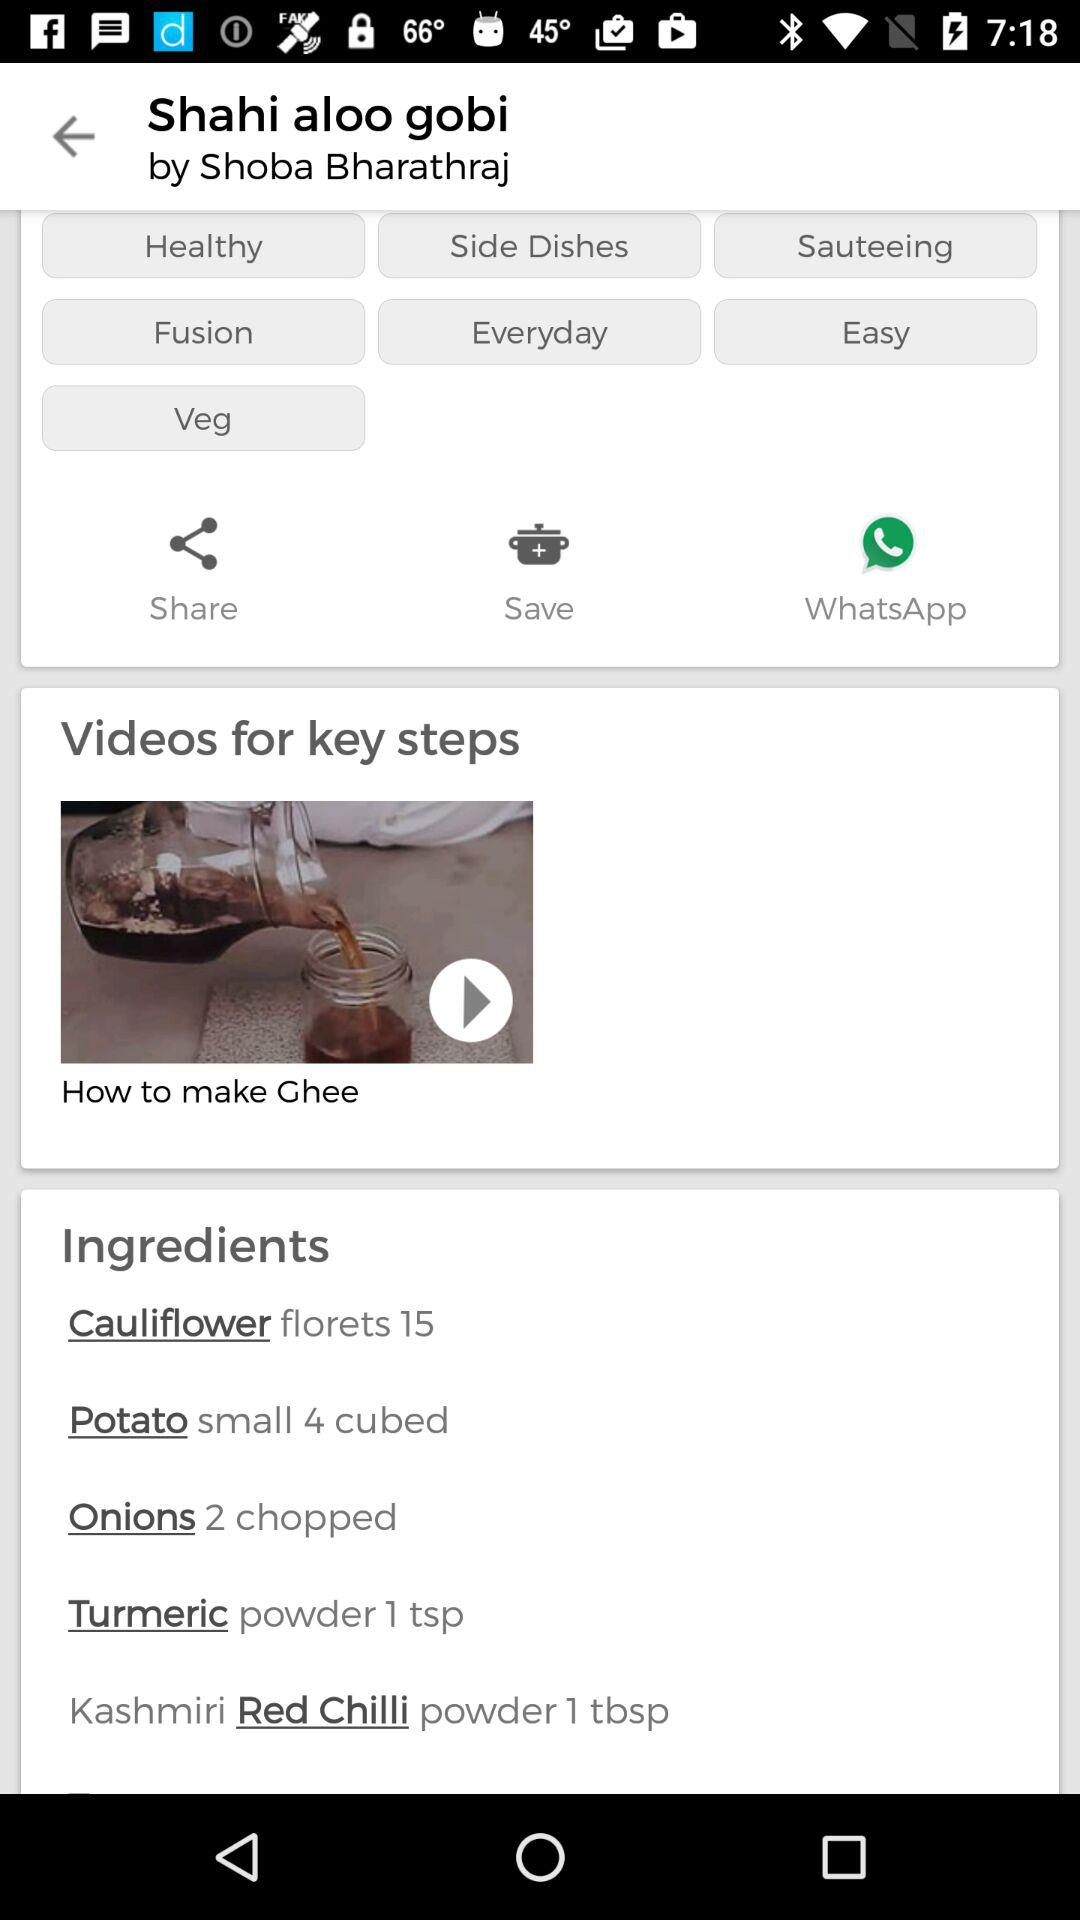Who posted Shahi aloo gobi? Shahi aloo gobi is posted by "Shoba Bharathraj". 